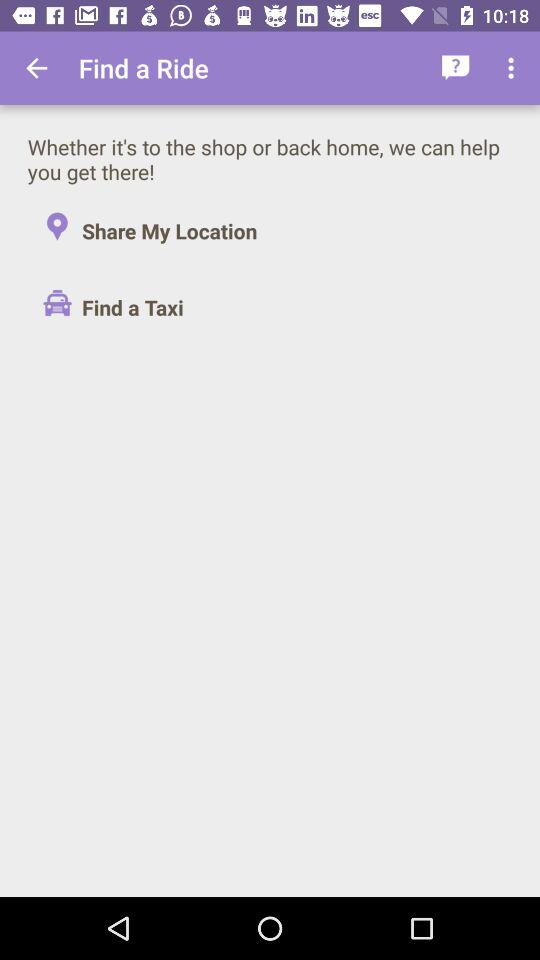What are the available options in "Find a Ride"? The available options in "Find a Ride" are "Share My Location" and "Find a Taxi". 